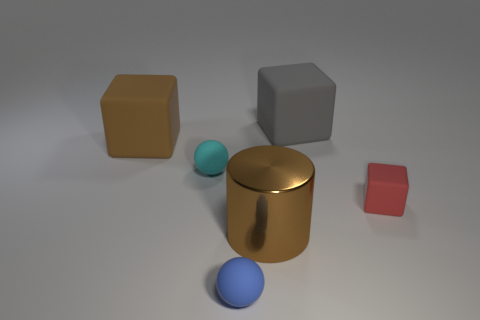The tiny rubber object that is on the right side of the cylinder on the right side of the rubber ball that is on the right side of the cyan thing is what color?
Offer a very short reply. Red. Are there any other things that are the same color as the metal cylinder?
Provide a short and direct response. Yes. Does the gray rubber thing have the same size as the brown cylinder?
Ensure brevity in your answer.  Yes. What number of objects are either matte objects behind the red matte block or small objects left of the metallic thing?
Provide a short and direct response. 4. What is the material of the large block behind the large rubber thing that is on the left side of the large shiny thing?
Your response must be concise. Rubber. How many other things are there of the same material as the red cube?
Ensure brevity in your answer.  4. Does the gray rubber object have the same shape as the cyan rubber thing?
Provide a succinct answer. No. There is a brown thing that is to the left of the cyan sphere; how big is it?
Your answer should be very brief. Large. Does the metallic cylinder have the same size as the brown object behind the red matte object?
Offer a very short reply. Yes. Is the number of blue balls behind the gray rubber object less than the number of tiny brown metallic objects?
Give a very brief answer. No. 